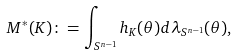<formula> <loc_0><loc_0><loc_500><loc_500>M ^ { * } ( K ) \colon = \int _ { S ^ { n - 1 } } h _ { K } ( \theta ) d \lambda _ { S ^ { n - 1 } } ( \theta ) ,</formula> 